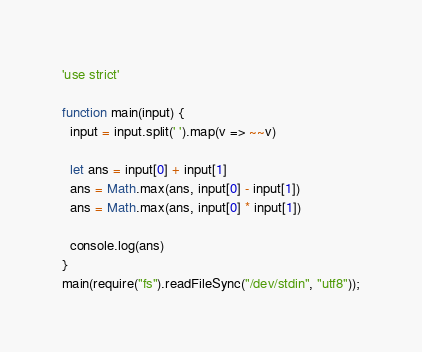Convert code to text. <code><loc_0><loc_0><loc_500><loc_500><_JavaScript_>'use strict'

function main(input) {
  input = input.split(' ').map(v => ~~v)

  let ans = input[0] + input[1]
  ans = Math.max(ans, input[0] - input[1])
  ans = Math.max(ans, input[0] * input[1])

  console.log(ans)
}
main(require("fs").readFileSync("/dev/stdin", "utf8"));</code> 